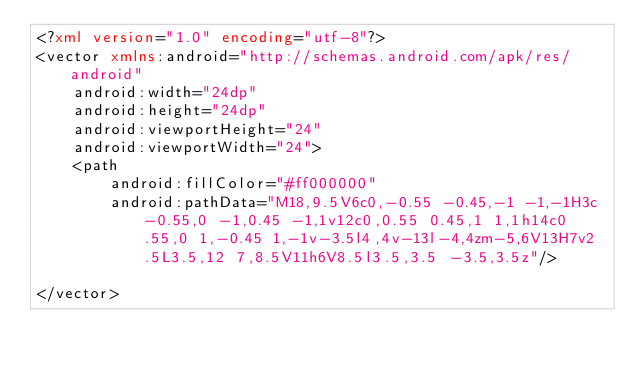Convert code to text. <code><loc_0><loc_0><loc_500><loc_500><_XML_><?xml version="1.0" encoding="utf-8"?>
<vector xmlns:android="http://schemas.android.com/apk/res/android"
    android:width="24dp"
    android:height="24dp"
    android:viewportHeight="24"
    android:viewportWidth="24">
    <path
        android:fillColor="#ff000000"
        android:pathData="M18,9.5V6c0,-0.55 -0.45,-1 -1,-1H3c-0.55,0 -1,0.45 -1,1v12c0,0.55 0.45,1 1,1h14c0.55,0 1,-0.45 1,-1v-3.5l4,4v-13l-4,4zm-5,6V13H7v2.5L3.5,12 7,8.5V11h6V8.5l3.5,3.5 -3.5,3.5z"/>

</vector></code> 